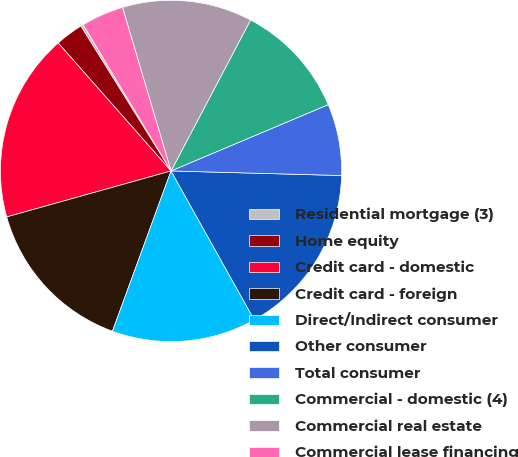<chart> <loc_0><loc_0><loc_500><loc_500><pie_chart><fcel>Residential mortgage (3)<fcel>Home equity<fcel>Credit card - domestic<fcel>Credit card - foreign<fcel>Direct/Indirect consumer<fcel>Other consumer<fcel>Total consumer<fcel>Commercial - domestic (4)<fcel>Commercial real estate<fcel>Commercial lease financing<nl><fcel>0.25%<fcel>2.64%<fcel>17.84%<fcel>15.08%<fcel>13.69%<fcel>16.46%<fcel>6.78%<fcel>10.93%<fcel>12.31%<fcel>4.02%<nl></chart> 